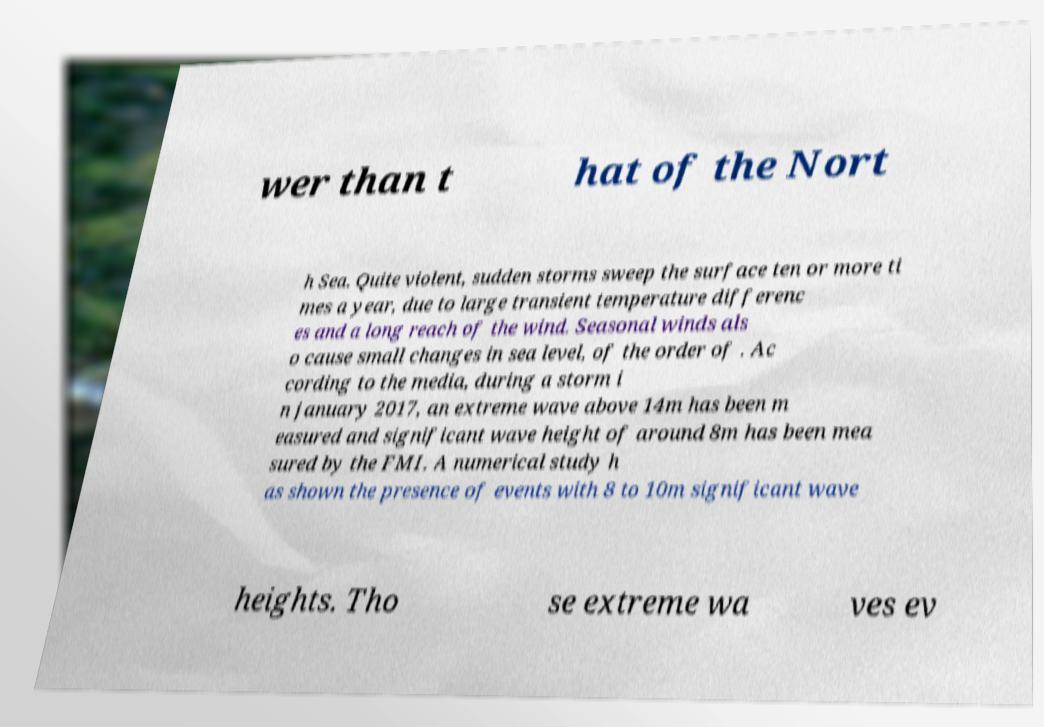There's text embedded in this image that I need extracted. Can you transcribe it verbatim? wer than t hat of the Nort h Sea. Quite violent, sudden storms sweep the surface ten or more ti mes a year, due to large transient temperature differenc es and a long reach of the wind. Seasonal winds als o cause small changes in sea level, of the order of . Ac cording to the media, during a storm i n january 2017, an extreme wave above 14m has been m easured and significant wave height of around 8m has been mea sured by the FMI. A numerical study h as shown the presence of events with 8 to 10m significant wave heights. Tho se extreme wa ves ev 